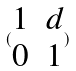Convert formula to latex. <formula><loc_0><loc_0><loc_500><loc_500>( \begin{matrix} 1 & d \\ 0 & 1 \end{matrix} )</formula> 